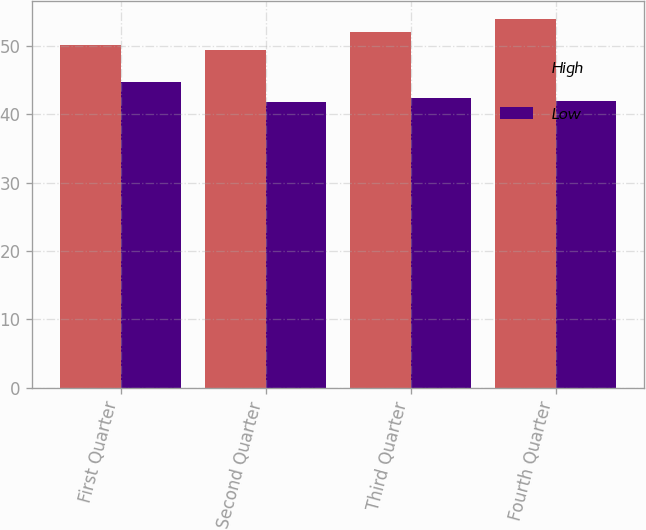Convert chart. <chart><loc_0><loc_0><loc_500><loc_500><stacked_bar_chart><ecel><fcel>First Quarter<fcel>Second Quarter<fcel>Third Quarter<fcel>Fourth Quarter<nl><fcel>High<fcel>50.19<fcel>49.44<fcel>51.98<fcel>53.9<nl><fcel>Low<fcel>44.7<fcel>41.85<fcel>42.39<fcel>41.92<nl></chart> 